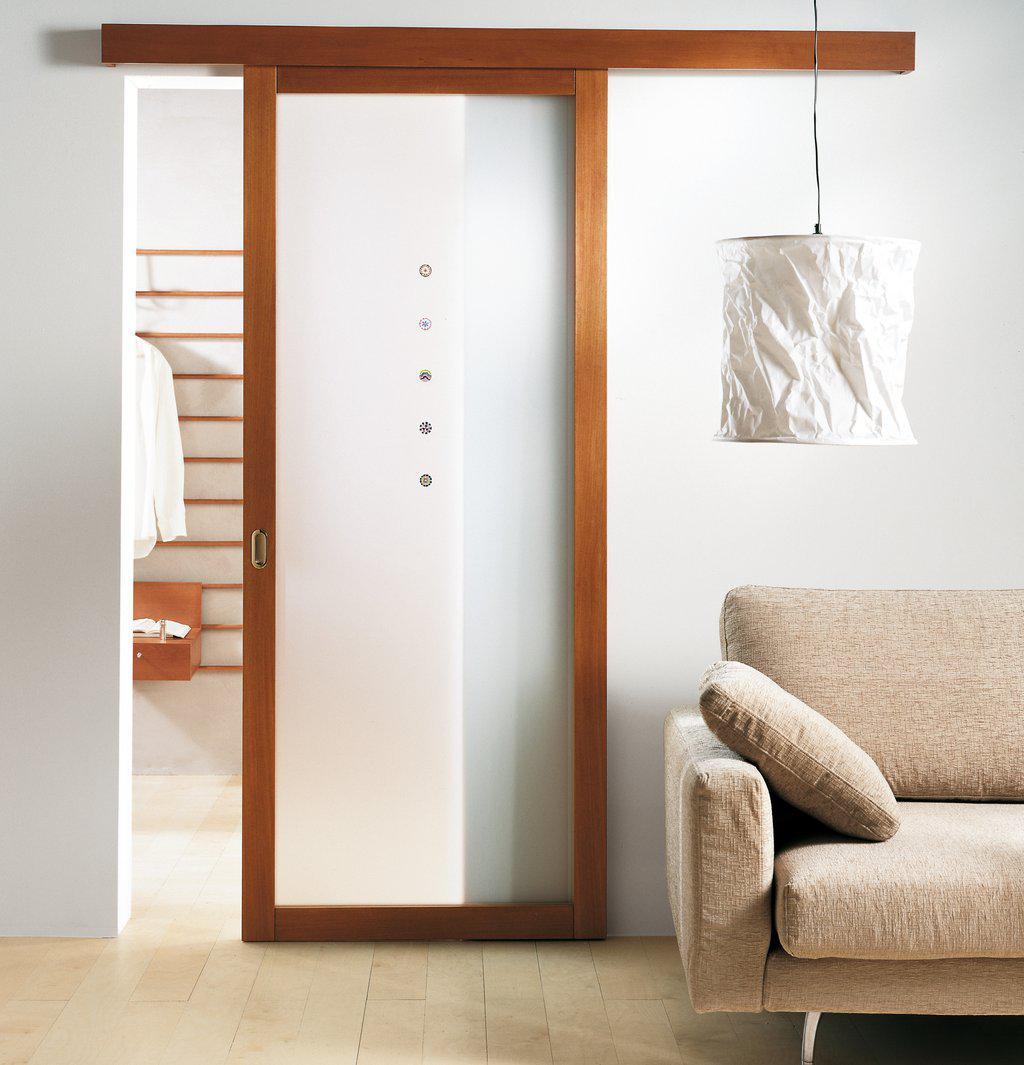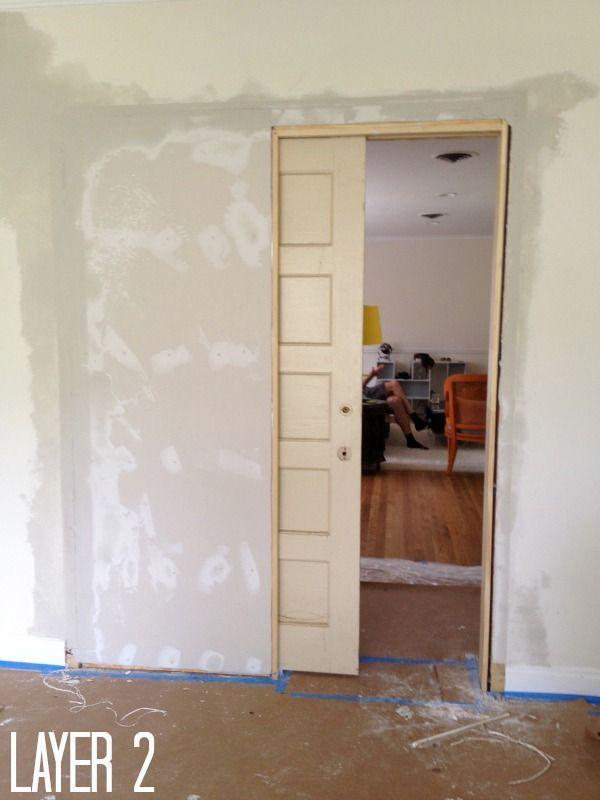The first image is the image on the left, the second image is the image on the right. Examine the images to the left and right. Is the description "There is a lamp in one of the images." accurate? Answer yes or no. Yes. 